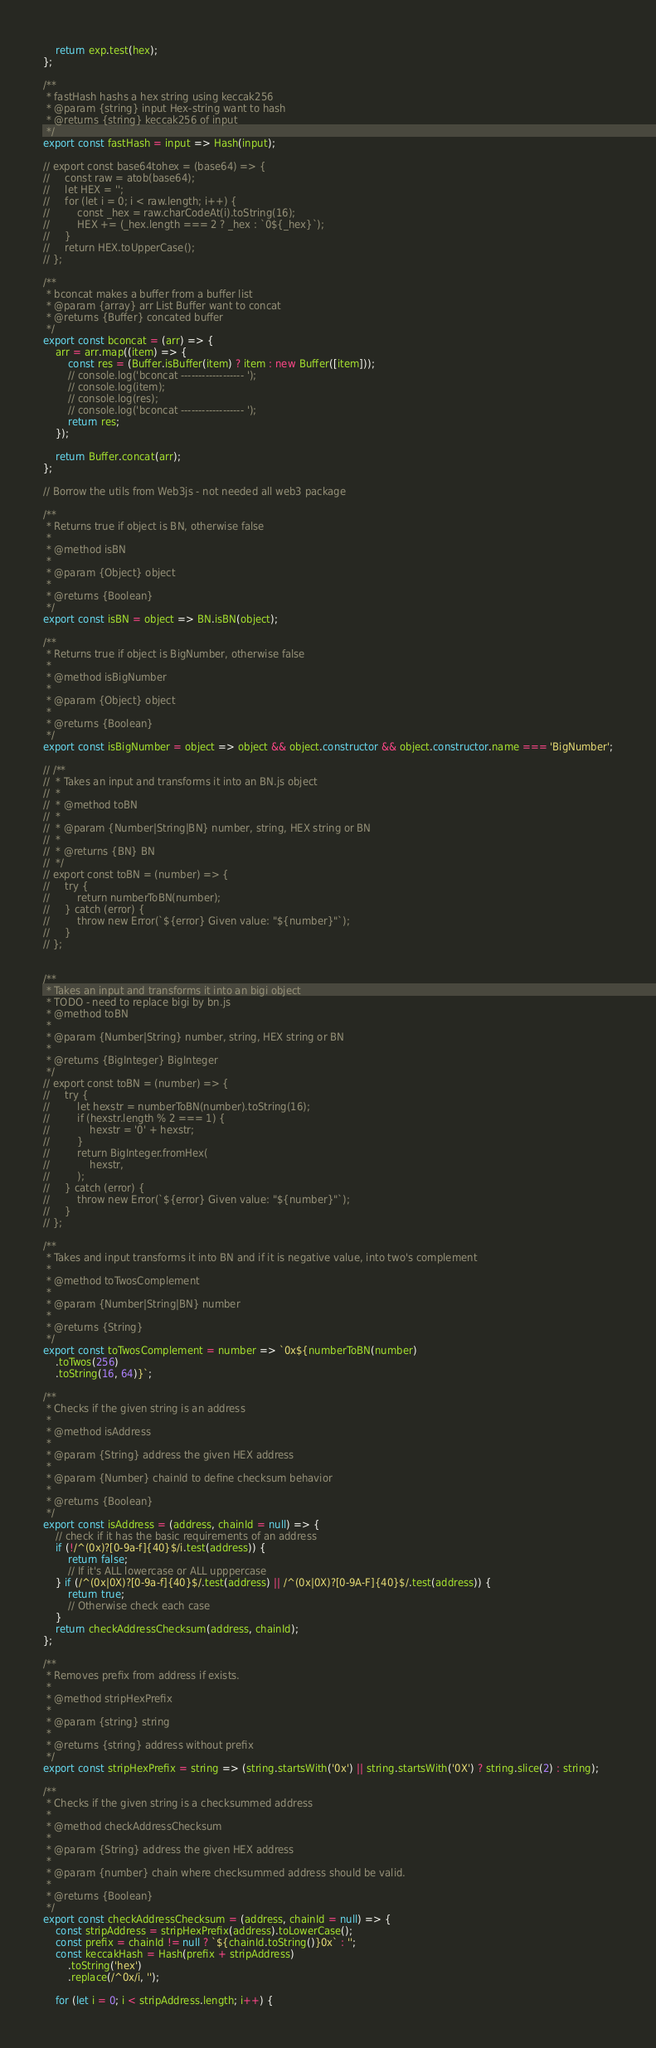Convert code to text. <code><loc_0><loc_0><loc_500><loc_500><_JavaScript_>    return exp.test(hex);
};

/**
 * fastHash hashs a hex string using keccak256
 * @param {string} input Hex-string want to hash
 * @returns {string} keccak256 of input
 */
export const fastHash = input => Hash(input);

// export const base64tohex = (base64) => {
//     const raw = atob(base64);
//     let HEX = '';
//     for (let i = 0; i < raw.length; i++) {
//         const _hex = raw.charCodeAt(i).toString(16);
//         HEX += (_hex.length === 2 ? _hex : `0${_hex}`);
//     }
//     return HEX.toUpperCase();
// };

/**
 * bconcat makes a buffer from a buffer list
 * @param {array} arr List Buffer want to concat
 * @returns {Buffer} concated buffer
 */
export const bconcat = (arr) => {
    arr = arr.map((item) => {
        const res = (Buffer.isBuffer(item) ? item : new Buffer([item]));
        // console.log('bconcat ------------------ ');
        // console.log(item);
        // console.log(res);
        // console.log('bconcat ------------------ ');
        return res;
    });

    return Buffer.concat(arr);
};

// Borrow the utils from Web3js - not needed all web3 package

/**
 * Returns true if object is BN, otherwise false
 *
 * @method isBN
 *
 * @param {Object} object
 *
 * @returns {Boolean}
 */
export const isBN = object => BN.isBN(object);

/**
 * Returns true if object is BigNumber, otherwise false
 *
 * @method isBigNumber
 *
 * @param {Object} object
 *
 * @returns {Boolean}
 */
export const isBigNumber = object => object && object.constructor && object.constructor.name === 'BigNumber';

// /**
//  * Takes an input and transforms it into an BN.js object
//  *
//  * @method toBN
//  *
//  * @param {Number|String|BN} number, string, HEX string or BN
//  *
//  * @returns {BN} BN
//  */
// export const toBN = (number) => {
//     try {
//         return numberToBN(number);
//     } catch (error) {
//         throw new Error(`${error} Given value: "${number}"`);
//     }
// };


/**
 * Takes an input and transforms it into an bigi object
 * TODO - need to replace bigi by bn.js
 * @method toBN
 *
 * @param {Number|String} number, string, HEX string or BN
 *
 * @returns {BigInteger} BigInteger
 */
// export const toBN = (number) => {
//     try {
//         let hexstr = numberToBN(number).toString(16);
//         if (hexstr.length % 2 === 1) {
//             hexstr = '0' + hexstr;
//         }
//         return BigInteger.fromHex(
//             hexstr,
//         );
//     } catch (error) {
//         throw new Error(`${error} Given value: "${number}"`);
//     }
// };

/**
 * Takes and input transforms it into BN and if it is negative value, into two's complement
 *
 * @method toTwosComplement
 *
 * @param {Number|String|BN} number
 *
 * @returns {String}
 */
export const toTwosComplement = number => `0x${numberToBN(number)
    .toTwos(256)
    .toString(16, 64)}`;

/**
 * Checks if the given string is an address
 *
 * @method isAddress
 *
 * @param {String} address the given HEX address
 *
 * @param {Number} chainId to define checksum behavior
 *
 * @returns {Boolean}
 */
export const isAddress = (address, chainId = null) => {
    // check if it has the basic requirements of an address
    if (!/^(0x)?[0-9a-f]{40}$/i.test(address)) {
        return false;
        // If it's ALL lowercase or ALL upppercase
    } if (/^(0x|0X)?[0-9a-f]{40}$/.test(address) || /^(0x|0X)?[0-9A-F]{40}$/.test(address)) {
        return true;
        // Otherwise check each case
    }
    return checkAddressChecksum(address, chainId);
};

/**
 * Removes prefix from address if exists.
 *
 * @method stripHexPrefix
 *
 * @param {string} string
 *
 * @returns {string} address without prefix
 */
export const stripHexPrefix = string => (string.startsWith('0x') || string.startsWith('0X') ? string.slice(2) : string);

/**
 * Checks if the given string is a checksummed address
 *
 * @method checkAddressChecksum
 *
 * @param {String} address the given HEX address
 *
 * @param {number} chain where checksummed address should be valid.
 *
 * @returns {Boolean}
 */
export const checkAddressChecksum = (address, chainId = null) => {
    const stripAddress = stripHexPrefix(address).toLowerCase();
    const prefix = chainId != null ? `${chainId.toString()}0x` : '';
    const keccakHash = Hash(prefix + stripAddress)
        .toString('hex')
        .replace(/^0x/i, '');

    for (let i = 0; i < stripAddress.length; i++) {</code> 